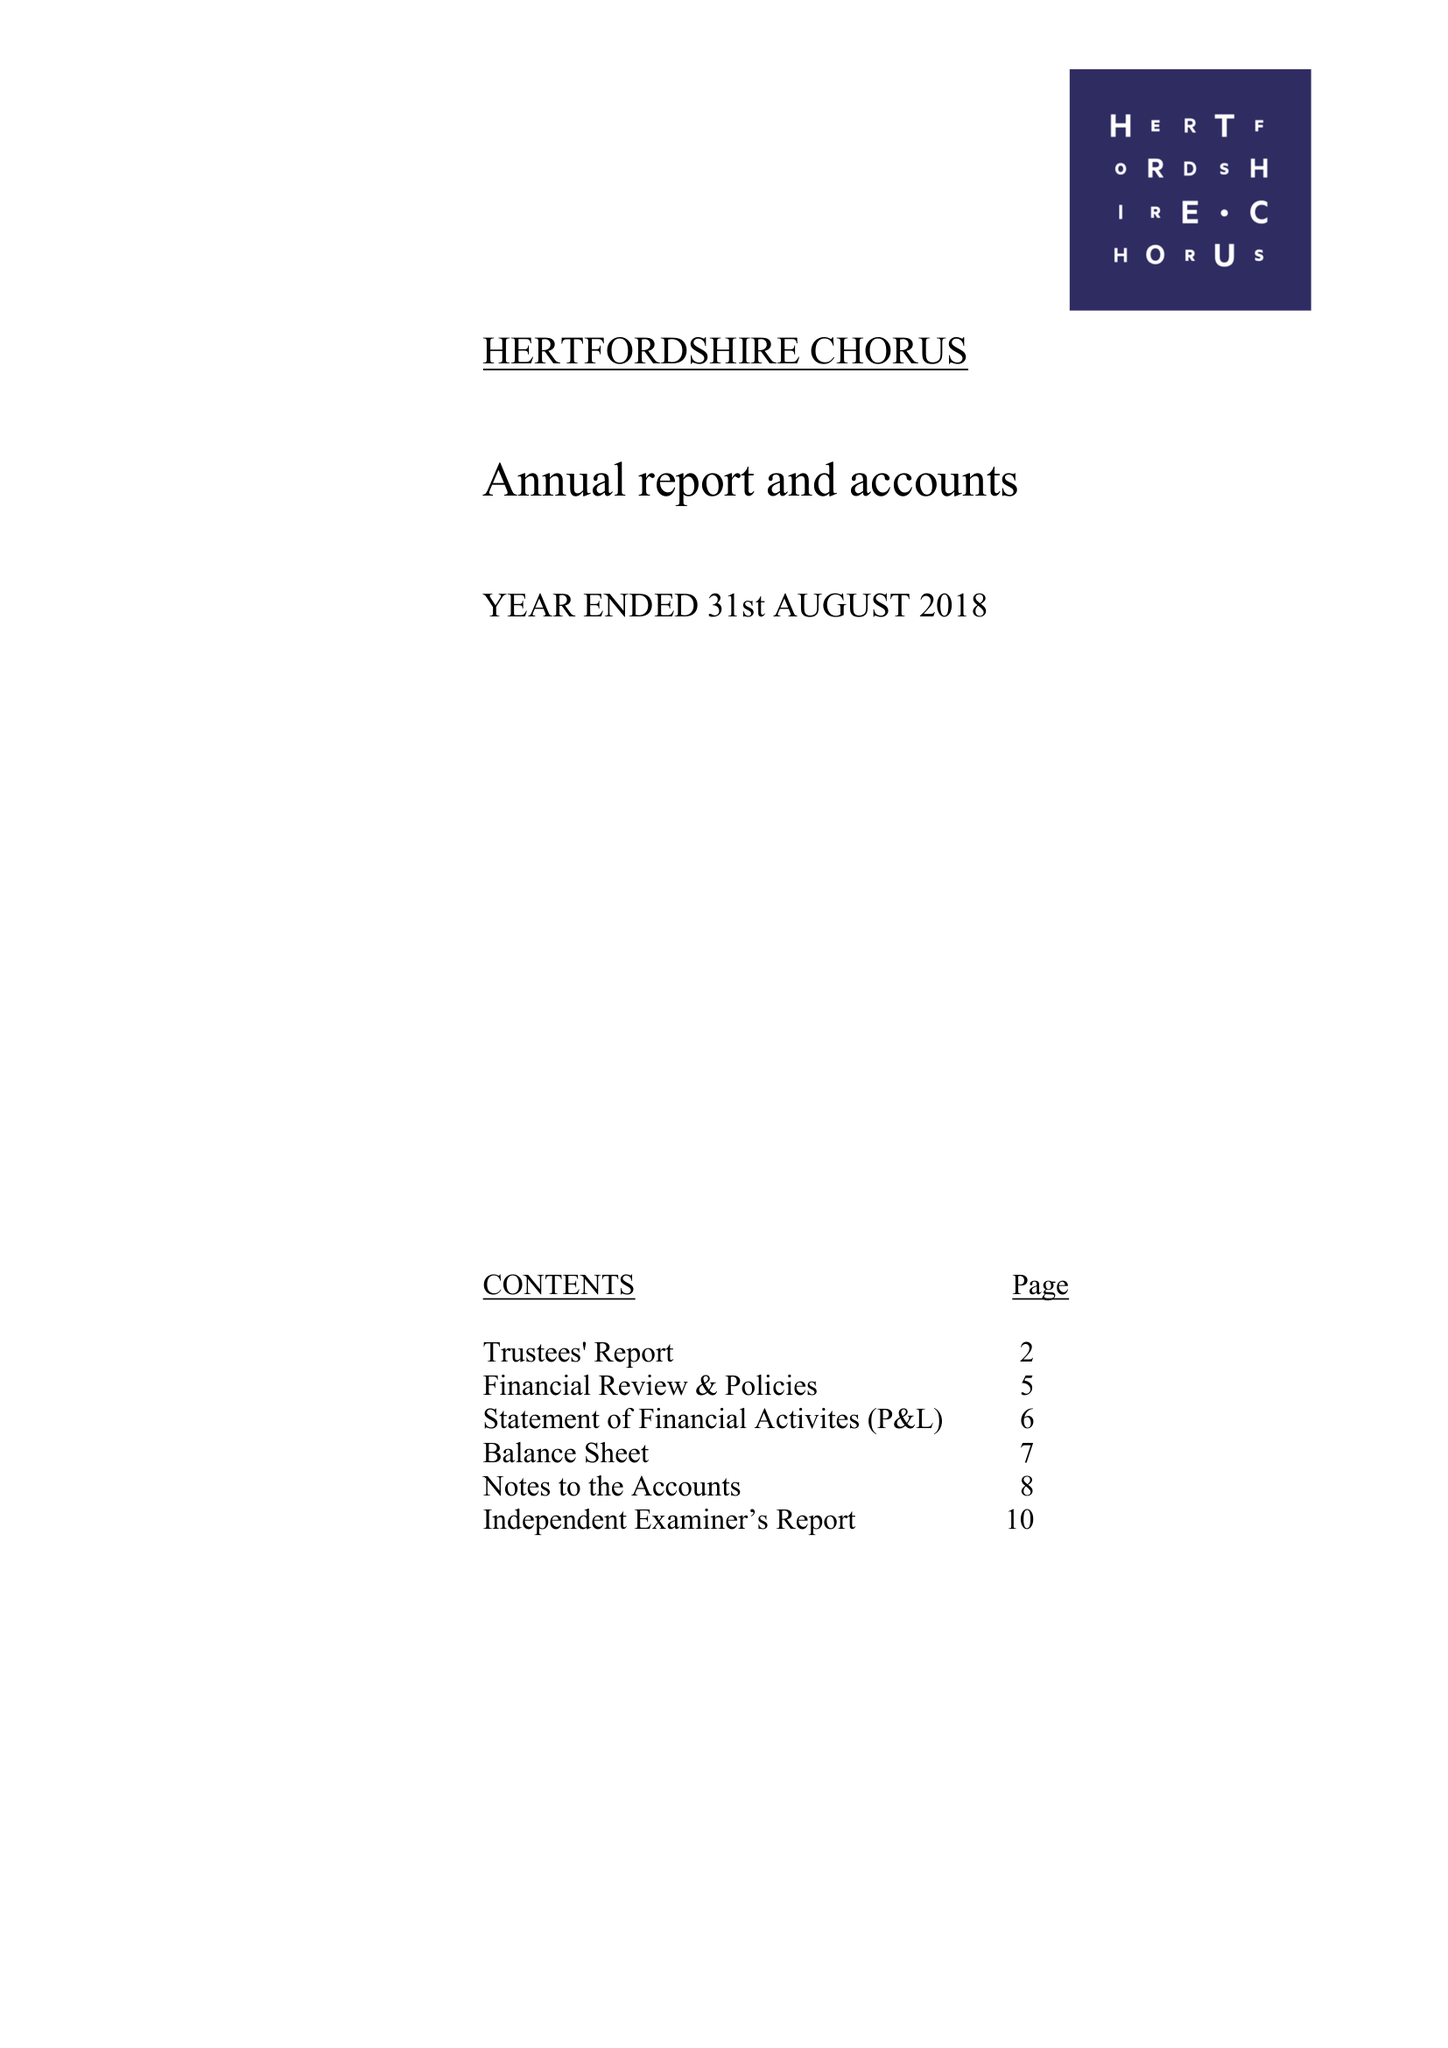What is the value for the address__post_town?
Answer the question using a single word or phrase. ST. ALBANS 